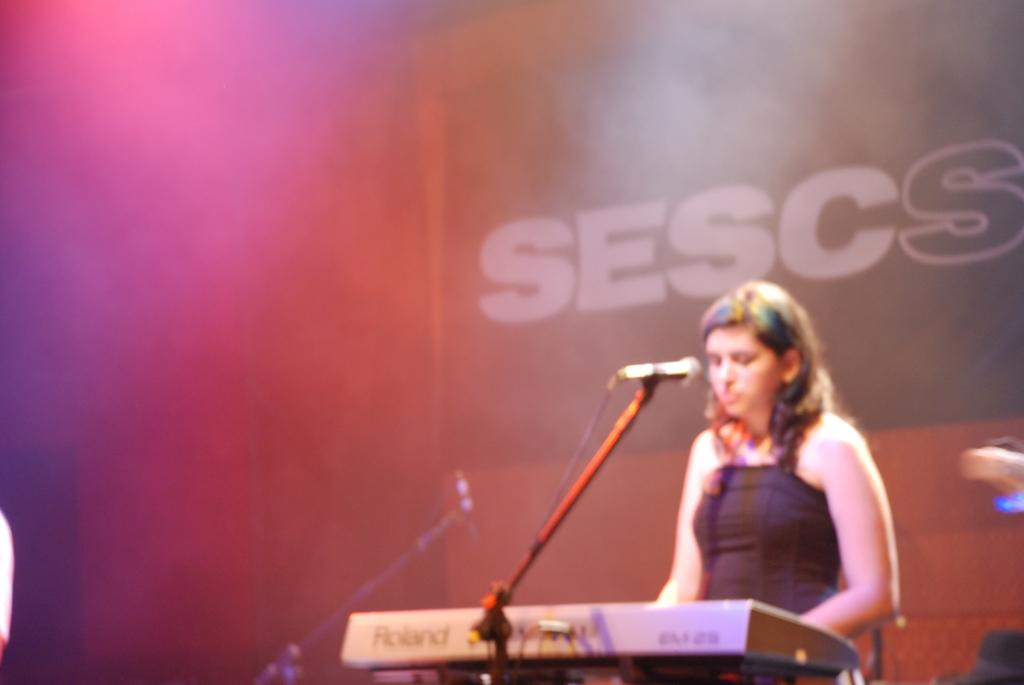What is the woman doing in the image? The woman is standing in front of the podium. What can be seen on the stand in the image? A mice is present on the stand. What is located behind the woman in the image? There is a poster with text in the background. What is the experience of the mice in the image? There is no indication of the mice's experience in the image, as it only shows the mice on the stand. 